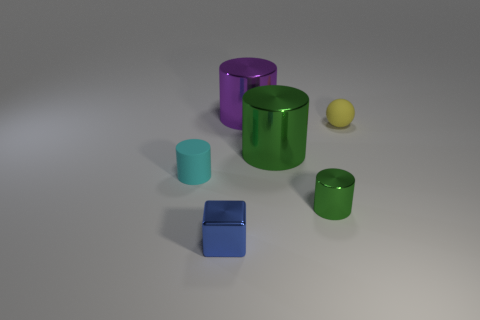Can you describe the lighting in the scene? The scene is illuminated by a soft overhead light source, creating gentle shadows beneath each object. The light appears diffused, as there are no harsh shadows or bright highlights, giving the scene a calm, evenly lit appearance. 